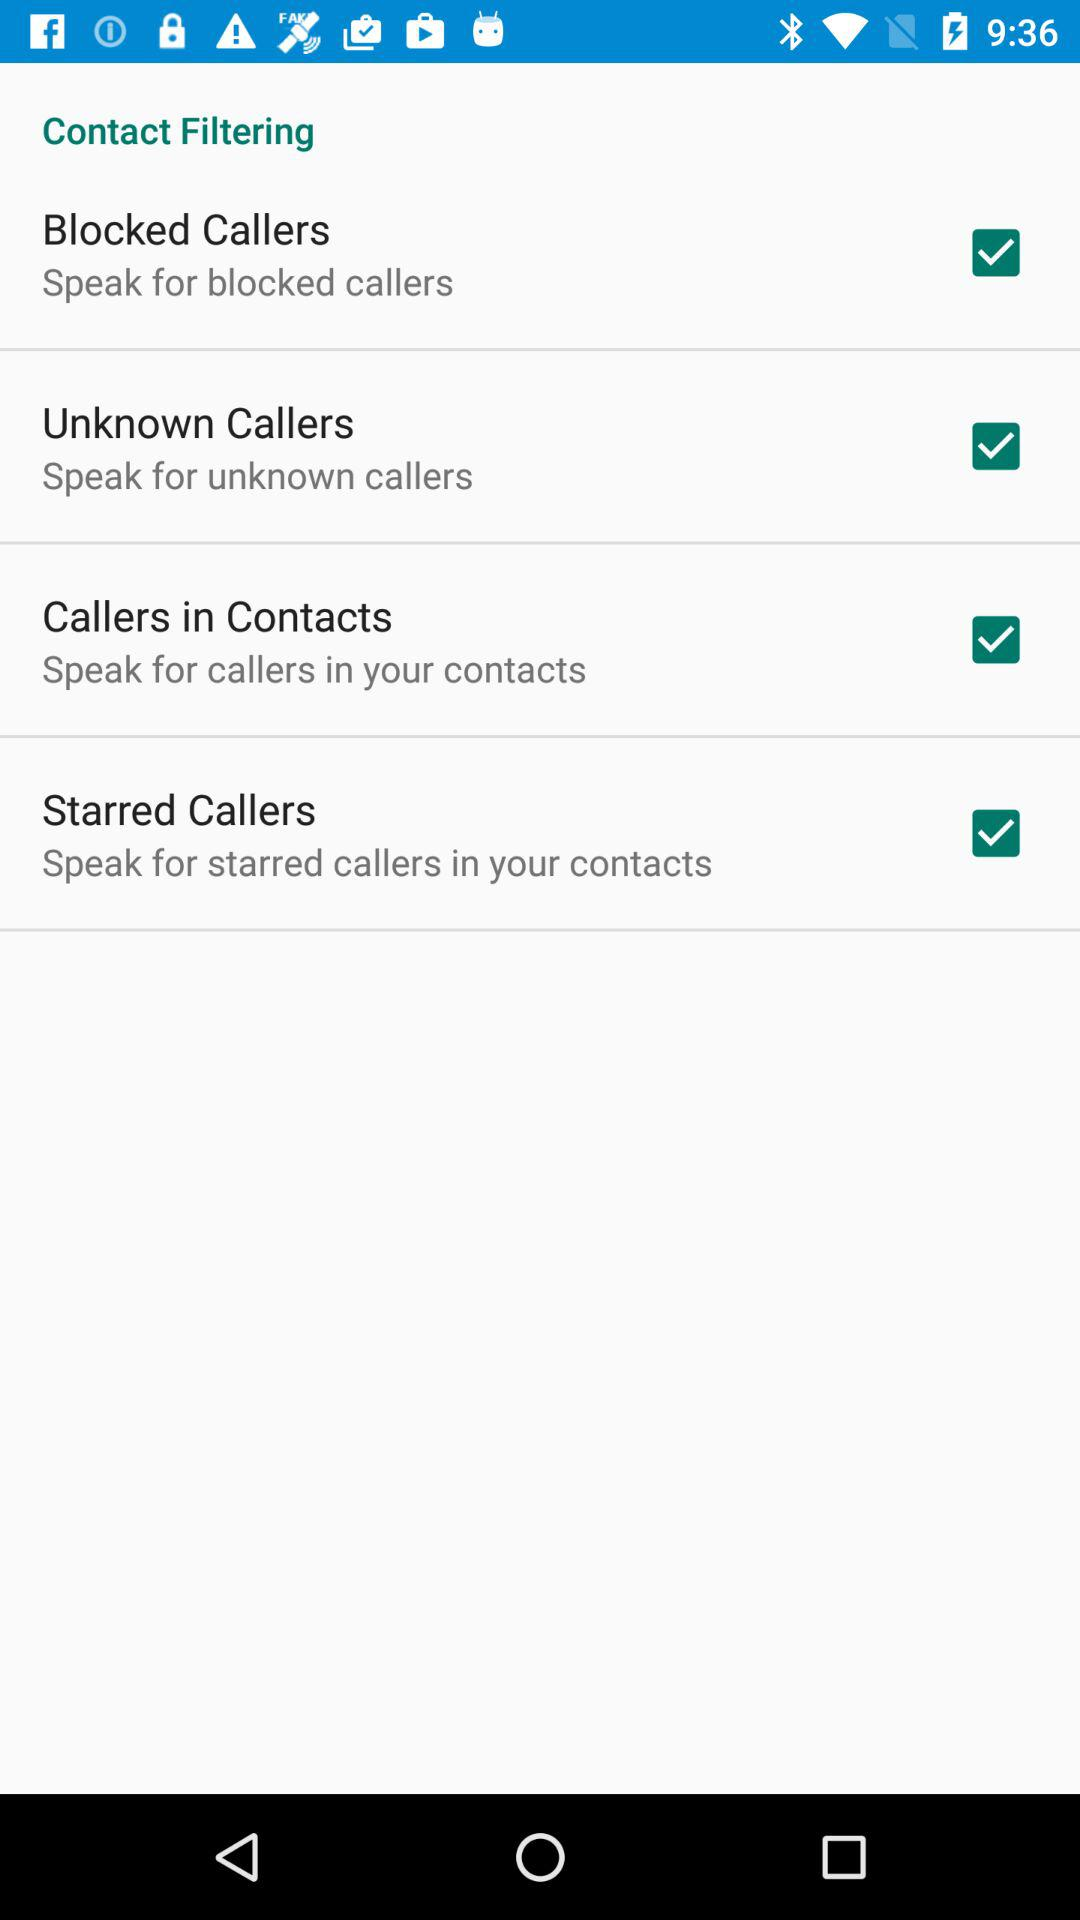What is the status of "Blocked callers"? The status of "Blocked callers" is "on". 